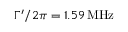<formula> <loc_0><loc_0><loc_500><loc_500>\Gamma ^ { \prime } / 2 \pi = 1 . 5 9 \, M H z</formula> 